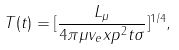Convert formula to latex. <formula><loc_0><loc_0><loc_500><loc_500>T ( t ) = [ \frac { L _ { \mu } } { 4 \pi \mu v _ { e } x p ^ { 2 } t \sigma } ] ^ { 1 / 4 } ,</formula> 